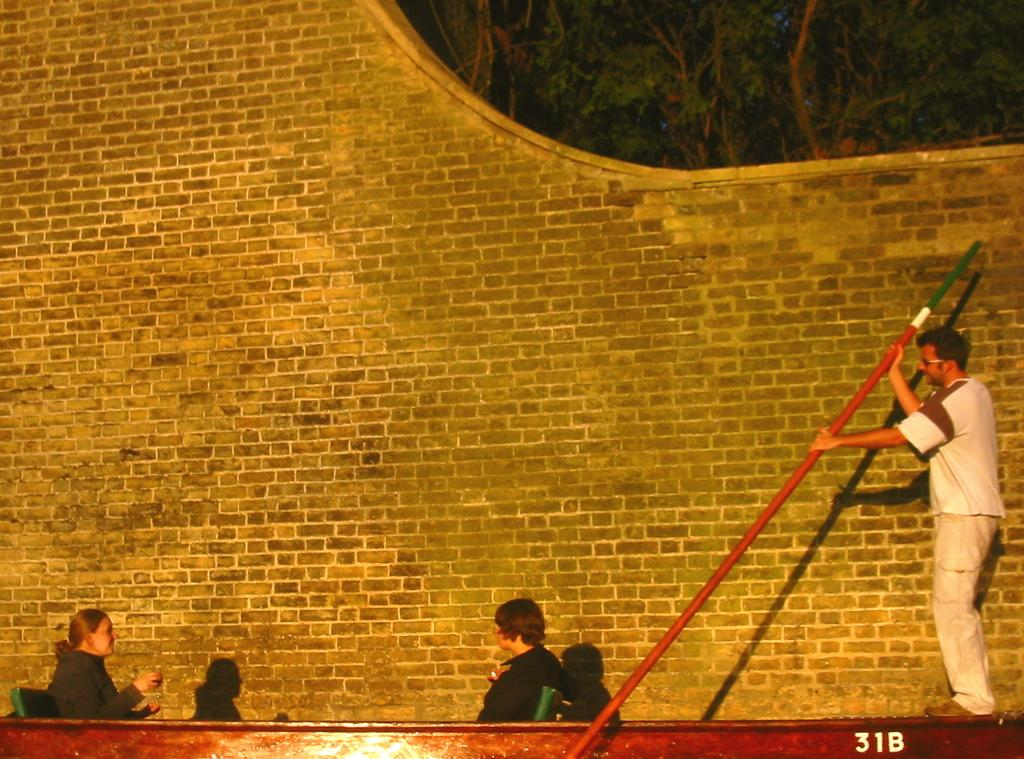What are the people in the image doing? The people in the image are in a boat. What is the person holding in the image? The person is holding a paddle. What can be seen in the background of the image? There are trees in the background of the image. What is visible near the boat in the image? There is a wall visible in the image. What type of opinion can be seen expressed by the trees in the image? Trees do not express opinions, as they are inanimate objects. 